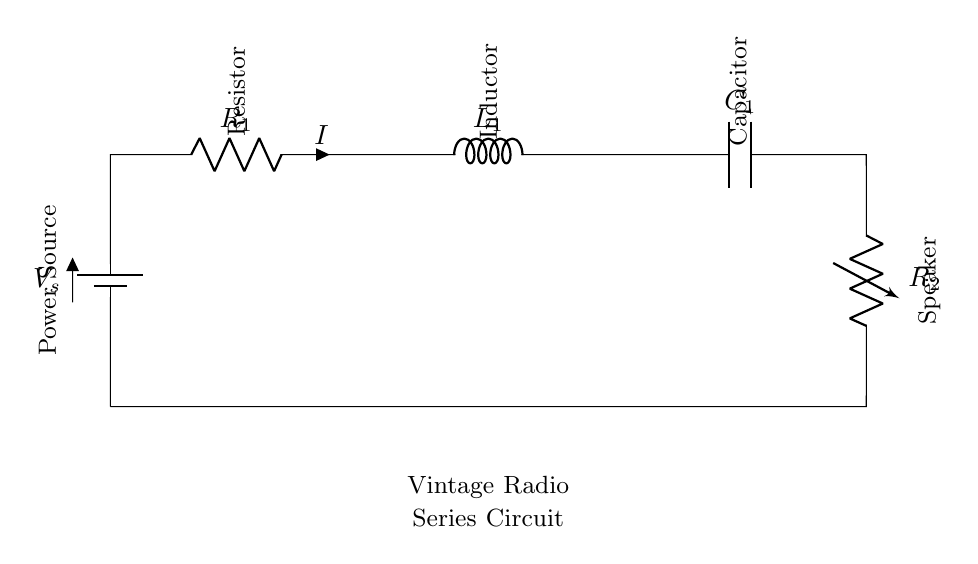What is the power source in the circuit? The power source in the circuit is represented by the symbol for the battery, labeled as V_s.
Answer: V_s What type of circuit is this? The circuit connects components in a single path, which is characteristic of a series circuit.
Answer: Series circuit What is the component labeled R1? R1 is a resistor, indicated by the R symbol in the circuit.
Answer: Resistor Which component is responsible for storing energy in the circuit? The inductor, labeled L1 in the circuit, is responsible for storing energy in the form of a magnetic field.
Answer: Inductor How many main components are in this circuit? The circuit includes five main components: a power source, a resistor, an inductor, a capacitor, and a speaker.
Answer: Five What is the function of C1 in this circuit? The capacitor labeled C1 stores electrical energy temporarily and can smooth voltage fluctuations in the circuit.
Answer: Capacitor What is the purpose of R2 in the circuit? R2, labeled as the speaker in the circuit, converts electrical energy into sound energy as part of the audio output.
Answer: Speaker 